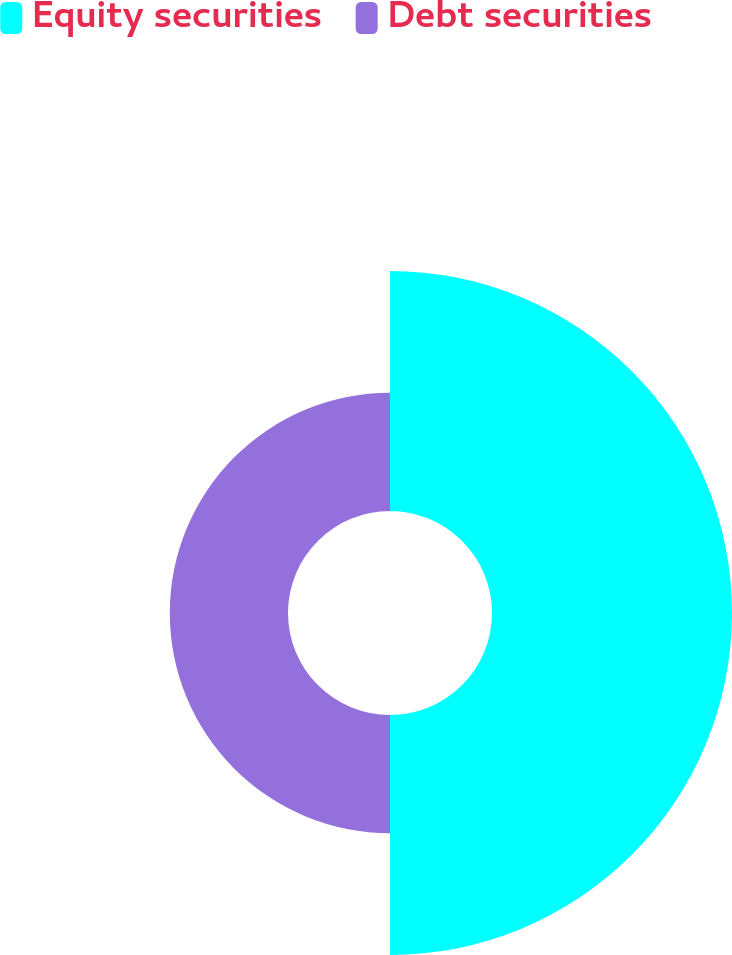<chart> <loc_0><loc_0><loc_500><loc_500><pie_chart><fcel>Equity securities<fcel>Debt securities<nl><fcel>67.0%<fcel>33.0%<nl></chart> 